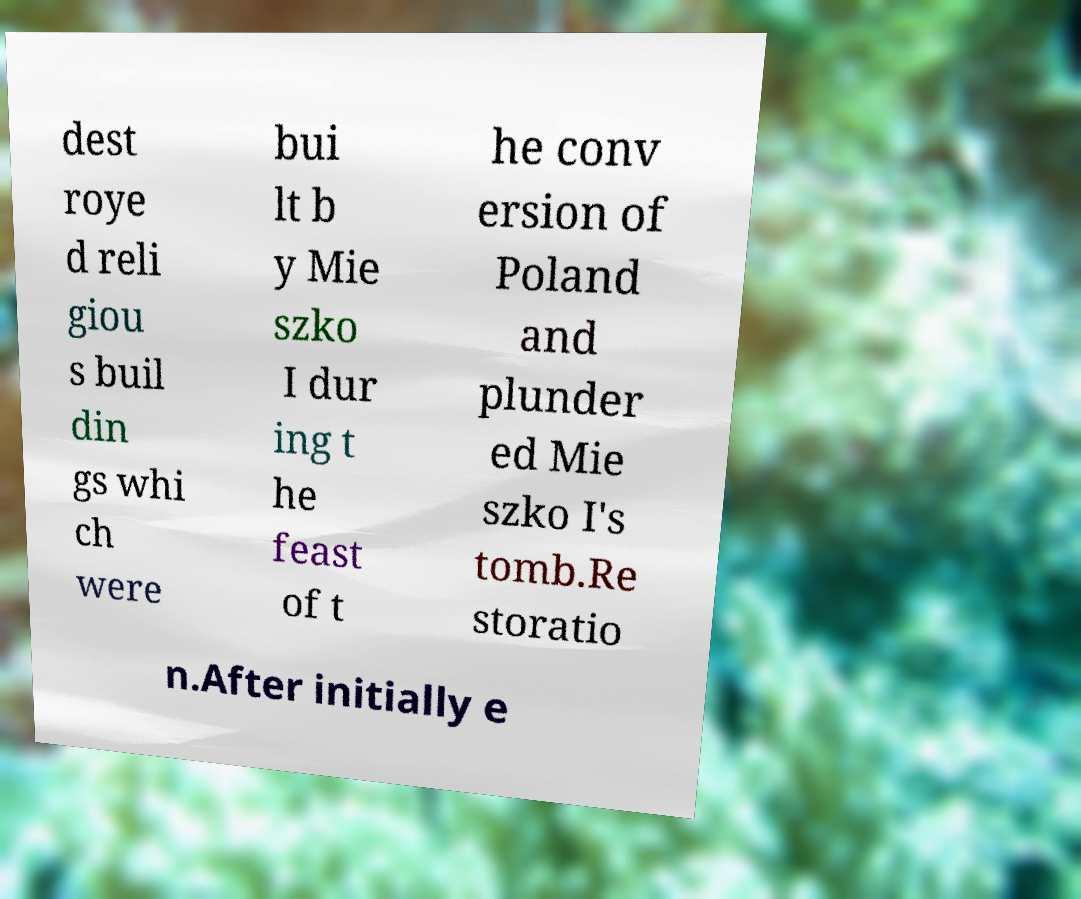Please identify and transcribe the text found in this image. dest roye d reli giou s buil din gs whi ch were bui lt b y Mie szko I dur ing t he feast of t he conv ersion of Poland and plunder ed Mie szko I's tomb.Re storatio n.After initially e 